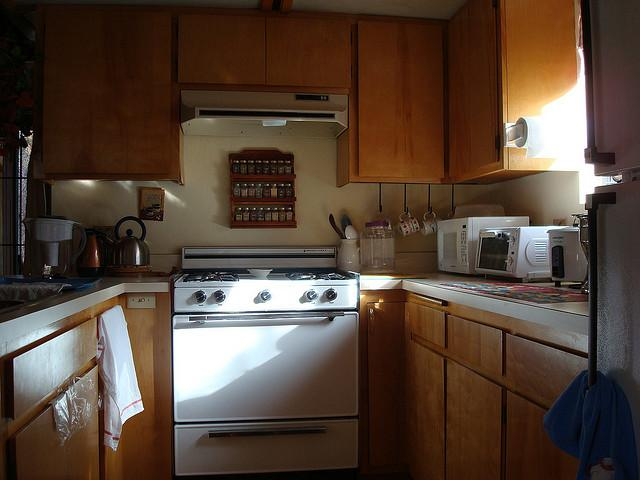What is the shorter rectangular appliance called? Please explain your reasoning. microwave. A white rectangular microwave sits in the corner. 